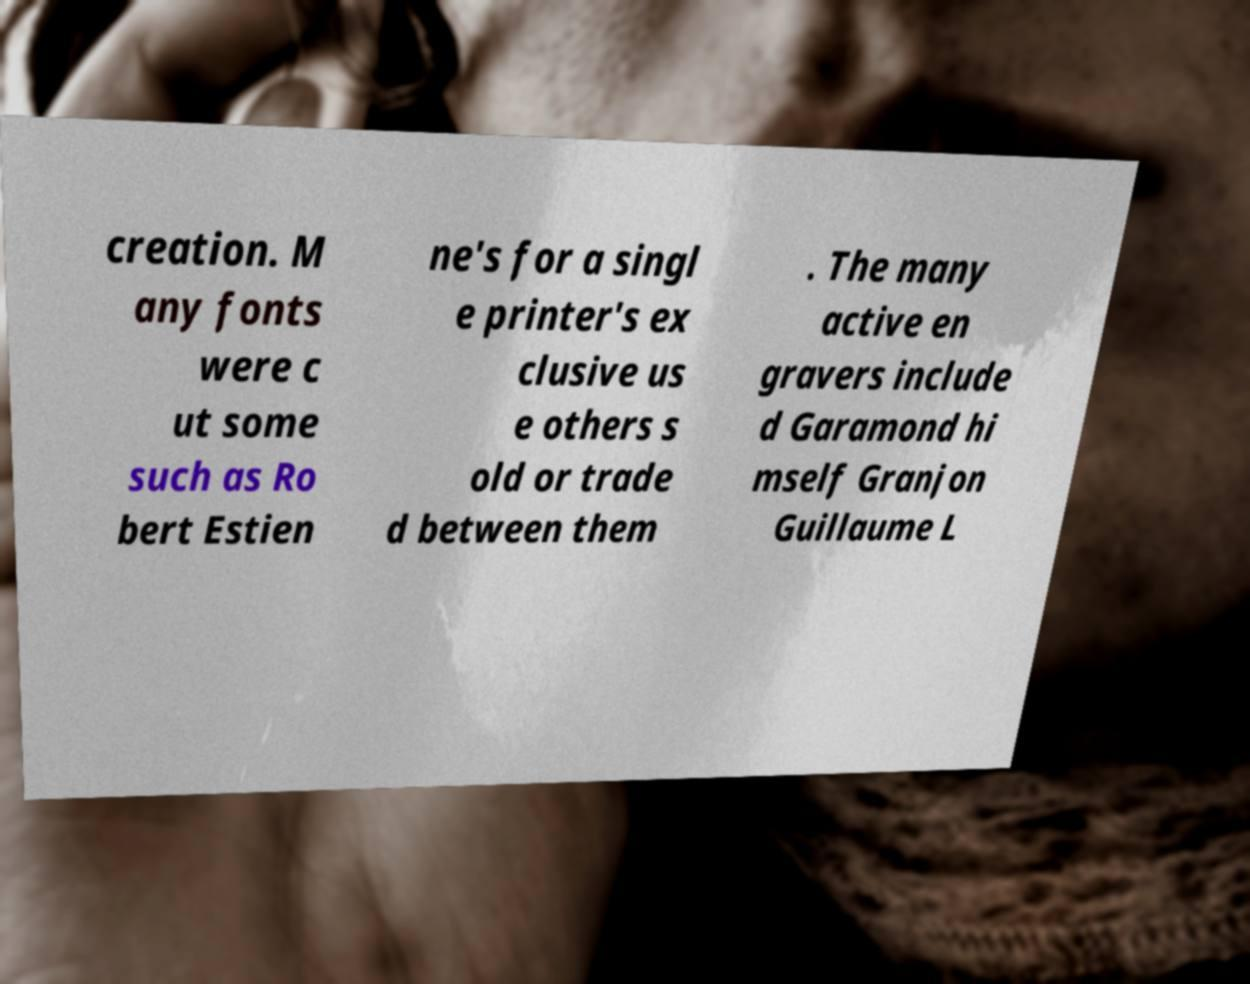There's text embedded in this image that I need extracted. Can you transcribe it verbatim? creation. M any fonts were c ut some such as Ro bert Estien ne's for a singl e printer's ex clusive us e others s old or trade d between them . The many active en gravers include d Garamond hi mself Granjon Guillaume L 